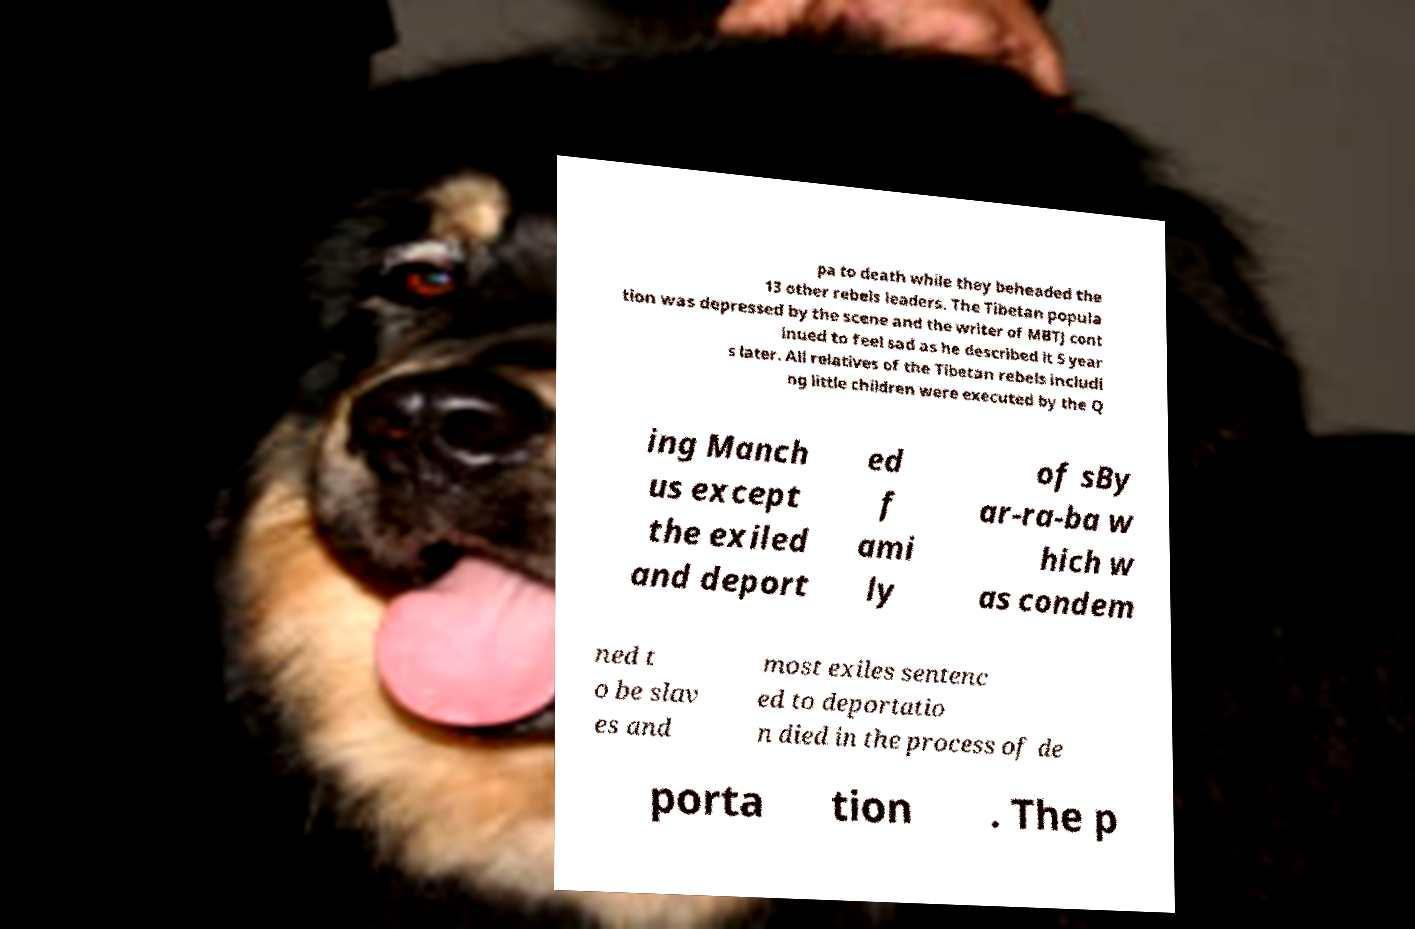Please identify and transcribe the text found in this image. pa to death while they beheaded the 13 other rebels leaders. The Tibetan popula tion was depressed by the scene and the writer of MBTJ cont inued to feel sad as he described it 5 year s later. All relatives of the Tibetan rebels includi ng little children were executed by the Q ing Manch us except the exiled and deport ed f ami ly of sBy ar-ra-ba w hich w as condem ned t o be slav es and most exiles sentenc ed to deportatio n died in the process of de porta tion . The p 